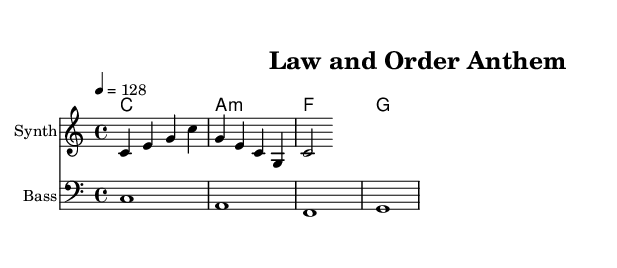What is the key signature of this music? The key signature is indicated by the absence of sharps or flats, which means it is in C major.
Answer: C major What is the time signature? The time signature is found at the beginning of the score, showing 4/4, which means there are four beats in each measure.
Answer: 4/4 What is the tempo marking? The tempo marking indicates the speed of the piece; it shows "4 = 128," meaning there are 128 beats per minute.
Answer: 128 How many measures are in the melody? By counting the grouped notes and looking for bar lines in the melody, we determine there are 4 measures visible.
Answer: 4 Which voices are present in the score? The score contains a melody (Synth), bass, and lyrics associated with the melody, which identifies the different musical roles.
Answer: Synth, Bass, Lyrics What is the chord progression used in the harmonies? By identifying the chords listed in the chord mode section, the progression is C major, A minor, F major, G major.
Answer: C, A minor, F, G What theme does the lyric reflect in the dance piece? The lyric "Stand strong for justice" shows a clear emphasis on justice, reflecting the patriotic and law-and-order theme of the dance.
Answer: Justice 